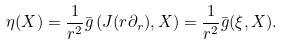Convert formula to latex. <formula><loc_0><loc_0><loc_500><loc_500>\eta ( X ) = \frac { 1 } { r ^ { 2 } } \bar { g } \left ( J ( r \partial _ { r } ) , X \right ) = \frac { 1 } { r ^ { 2 } } \bar { g } ( \xi , X ) .</formula> 